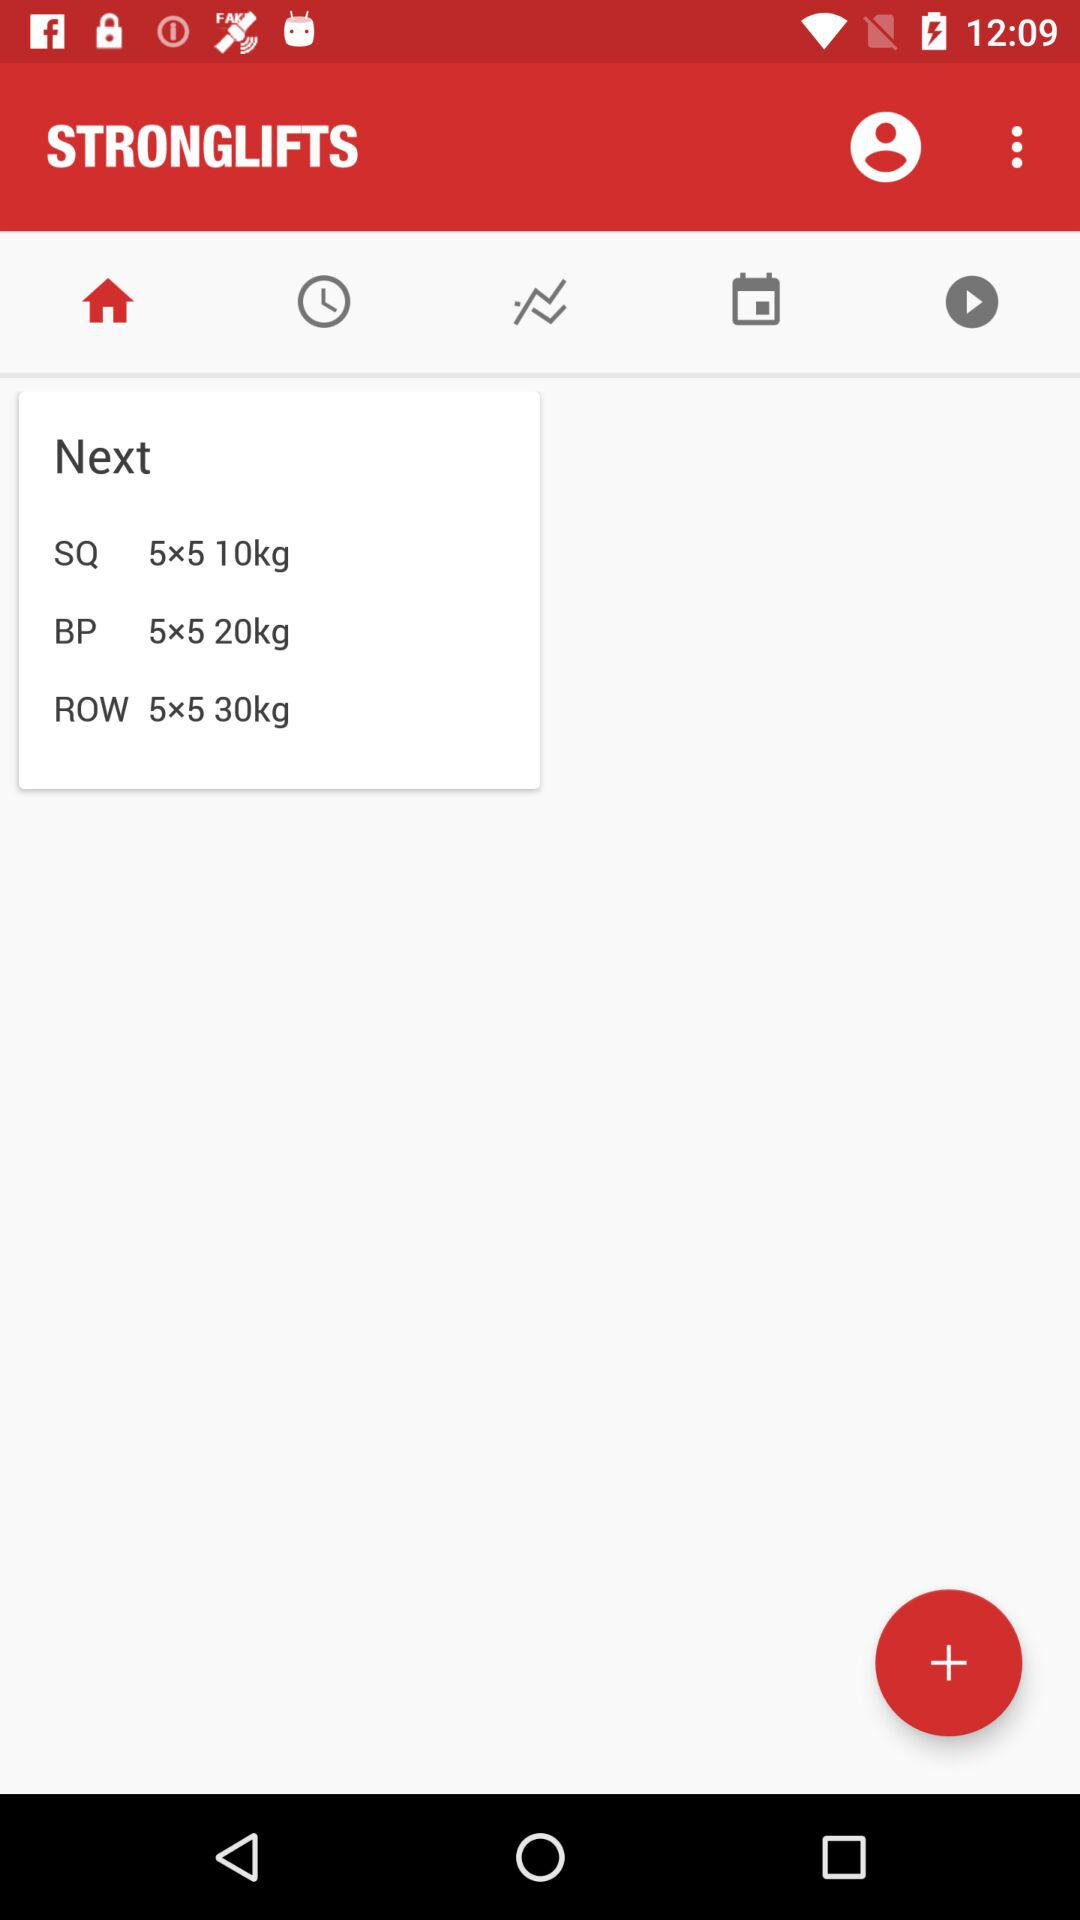What is mentioned for the "BP"? For the "BP", "5x5 20kg" is mentioned. 